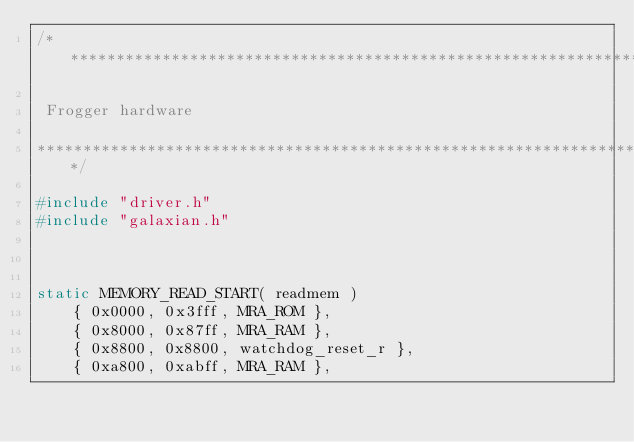Convert code to text. <code><loc_0><loc_0><loc_500><loc_500><_C_>/***************************************************************************

 Frogger hardware

***************************************************************************/

#include "driver.h"
#include "galaxian.h"



static MEMORY_READ_START( readmem )
	{ 0x0000, 0x3fff, MRA_ROM },
	{ 0x8000, 0x87ff, MRA_RAM },
	{ 0x8800, 0x8800, watchdog_reset_r },
	{ 0xa800, 0xabff, MRA_RAM },</code> 